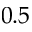<formula> <loc_0><loc_0><loc_500><loc_500>0 . 5</formula> 